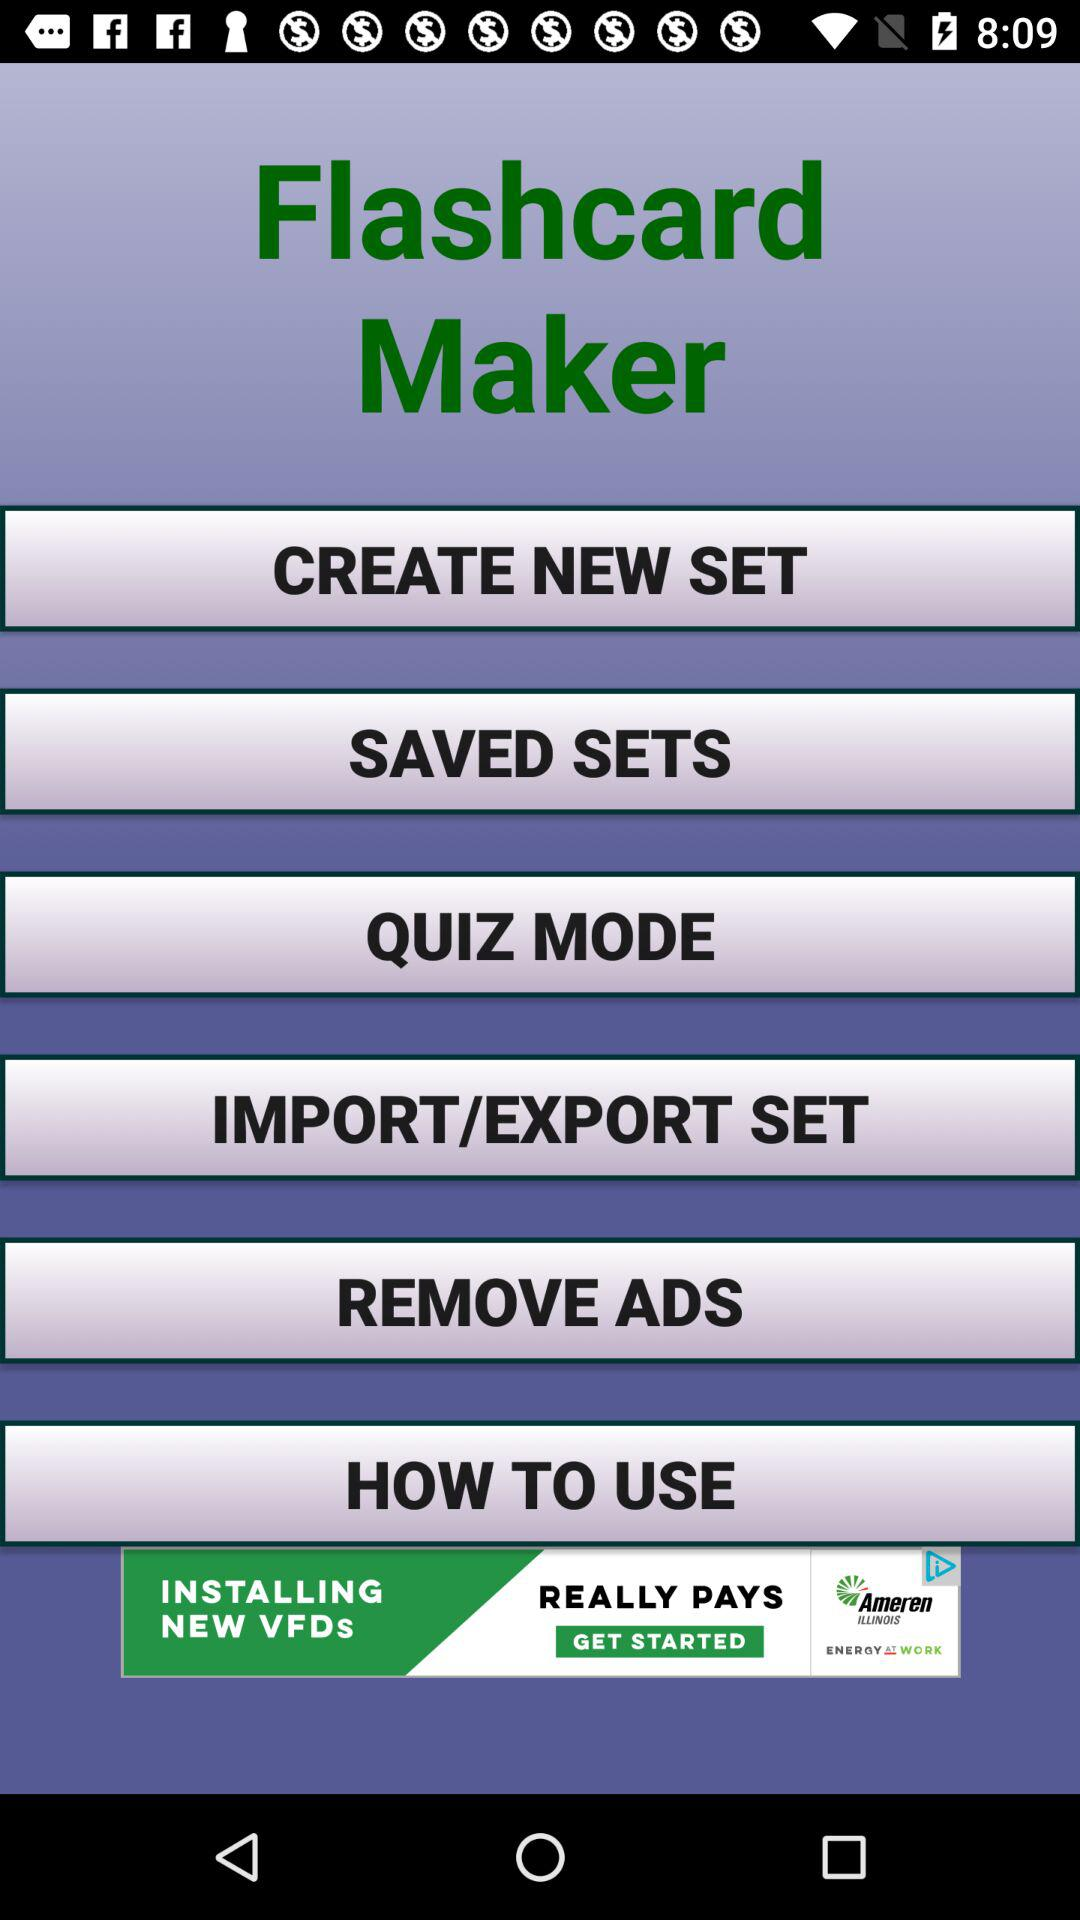What is the name of the application? The name of the application is "Flashcard Maker". 